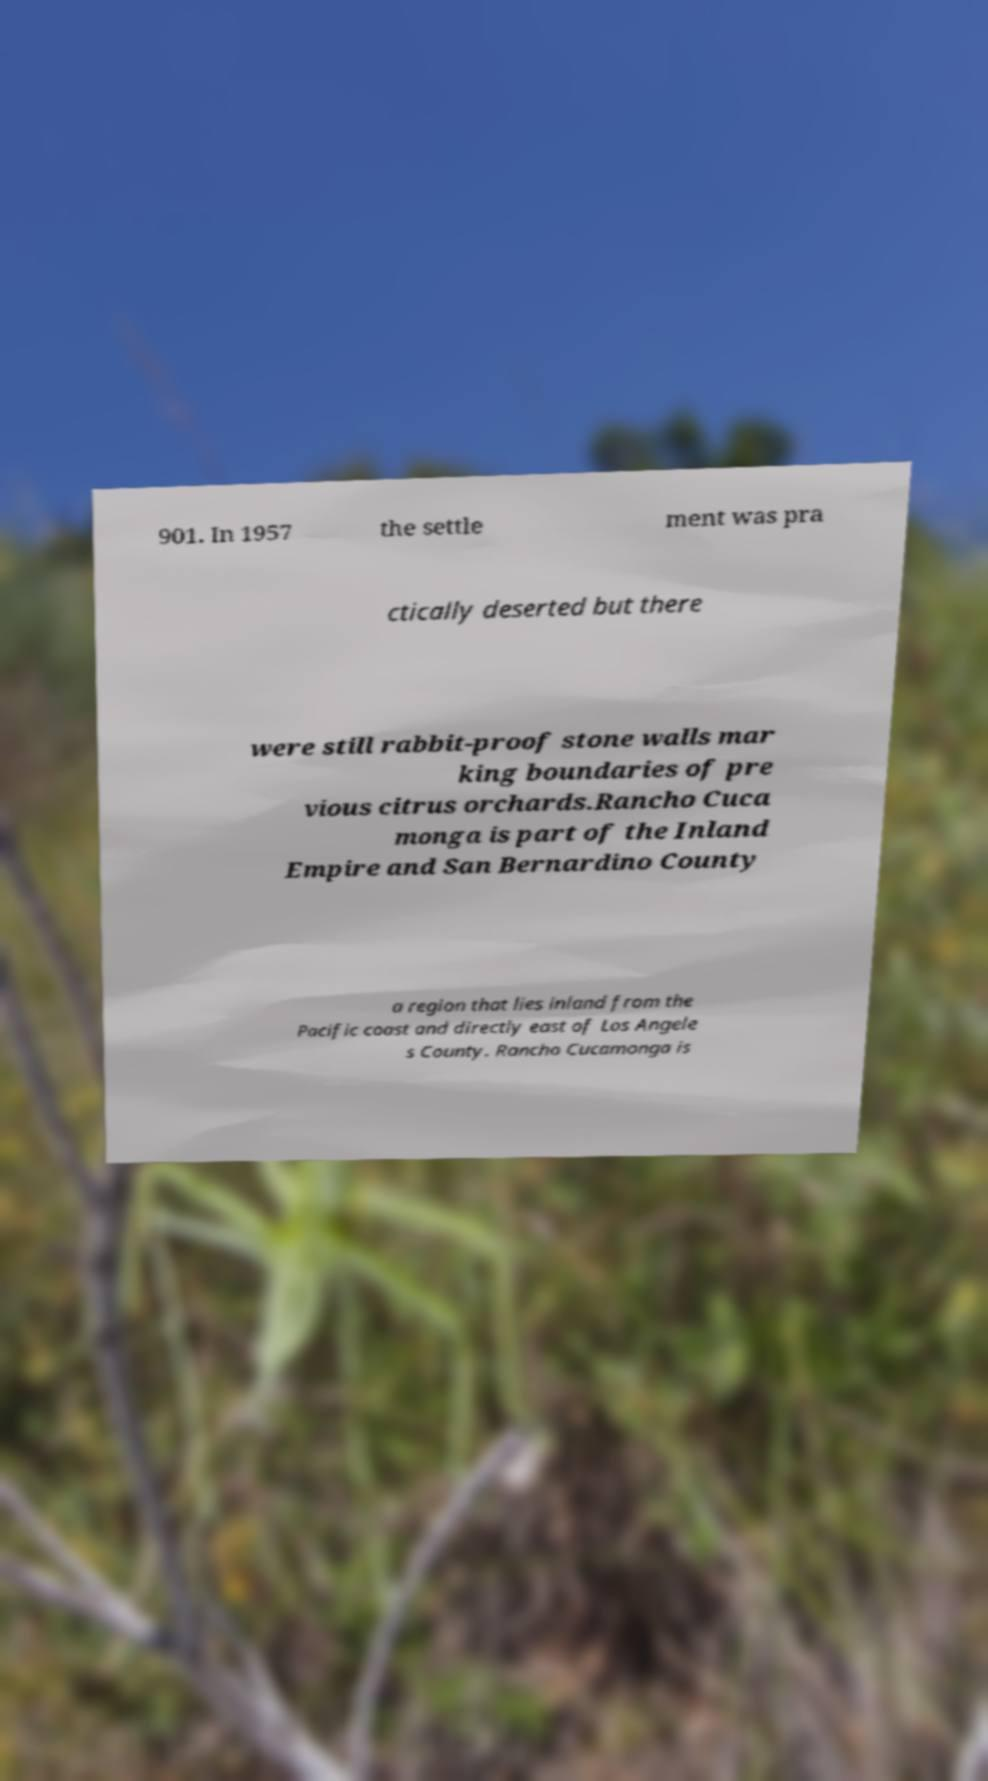For documentation purposes, I need the text within this image transcribed. Could you provide that? 901. In 1957 the settle ment was pra ctically deserted but there were still rabbit-proof stone walls mar king boundaries of pre vious citrus orchards.Rancho Cuca monga is part of the Inland Empire and San Bernardino County a region that lies inland from the Pacific coast and directly east of Los Angele s County. Rancho Cucamonga is 